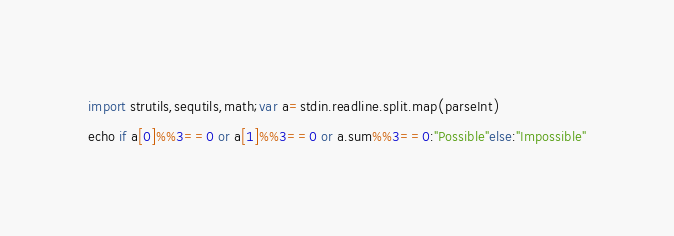<code> <loc_0><loc_0><loc_500><loc_500><_Nim_>import strutils,sequtils,math;var a=stdin.readline.split.map(parseInt)
echo if a[0]%%3==0 or a[1]%%3==0 or a.sum%%3==0:"Possible"else:"Impossible"</code> 